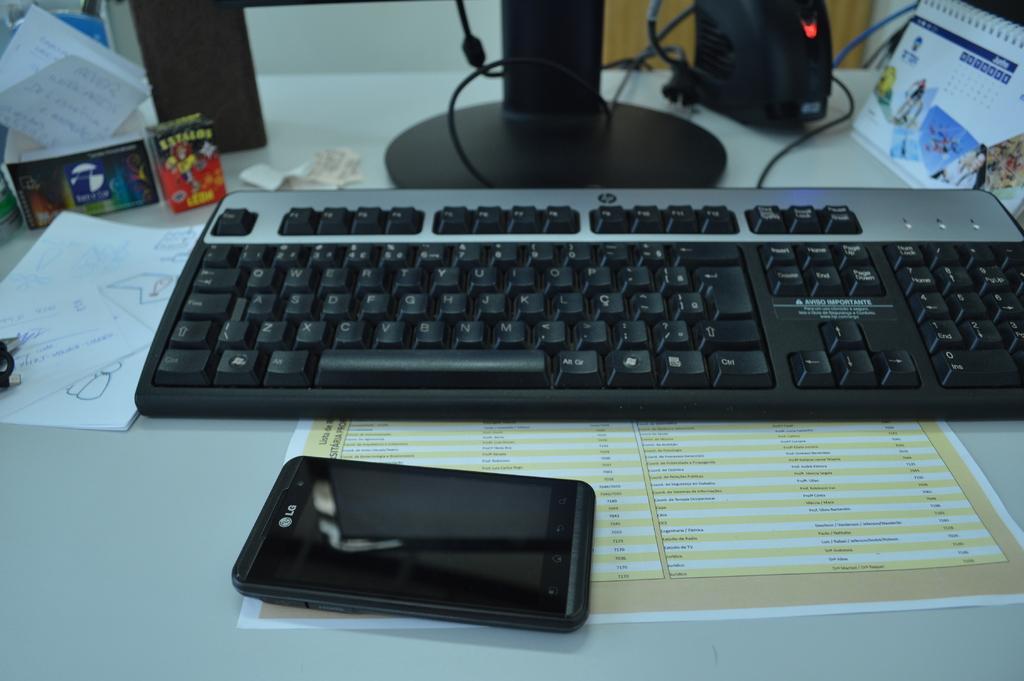Please provide a concise description of this image. On the table there is a keyboard, a mobile and a paper. To the right top corner there is a calendar. Beside the calendar there is a black object. And to the left side there is a paper and colorful box. 